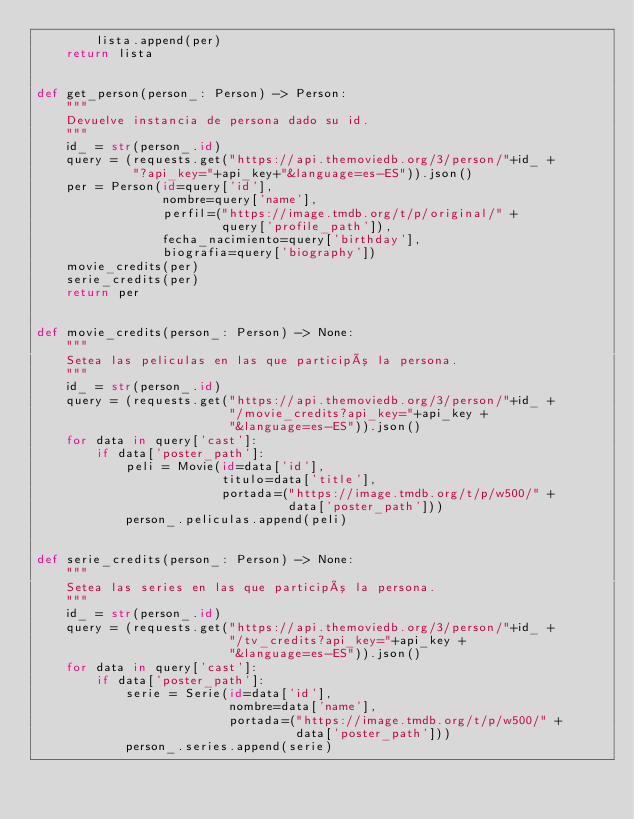Convert code to text. <code><loc_0><loc_0><loc_500><loc_500><_Python_>        lista.append(per)
    return lista


def get_person(person_: Person) -> Person:
    """
    Devuelve instancia de persona dado su id.
    """
    id_ = str(person_.id)
    query = (requests.get("https://api.themoviedb.org/3/person/"+id_ +
             "?api_key="+api_key+"&language=es-ES")).json()
    per = Person(id=query['id'],
                 nombre=query['name'],
                 perfil=("https://image.tmdb.org/t/p/original/" +
                         query['profile_path']),
                 fecha_nacimiento=query['birthday'],
                 biografia=query['biography'])
    movie_credits(per)
    serie_credits(per)
    return per


def movie_credits(person_: Person) -> None:
    """
    Setea las peliculas en las que participó la persona.
    """
    id_ = str(person_.id)
    query = (requests.get("https://api.themoviedb.org/3/person/"+id_ +
                          "/movie_credits?api_key="+api_key +
                          "&language=es-ES")).json()
    for data in query['cast']:
        if data['poster_path']:
            peli = Movie(id=data['id'],
                         titulo=data['title'],
                         portada=("https://image.tmdb.org/t/p/w500/" +
                                  data['poster_path']))
            person_.peliculas.append(peli)


def serie_credits(person_: Person) -> None:
    """
    Setea las series en las que participó la persona.
    """
    id_ = str(person_.id)
    query = (requests.get("https://api.themoviedb.org/3/person/"+id_ +
                          "/tv_credits?api_key="+api_key +
                          "&language=es-ES")).json()
    for data in query['cast']:
        if data['poster_path']:
            serie = Serie(id=data['id'],
                          nombre=data['name'],
                          portada=("https://image.tmdb.org/t/p/w500/" +
                                   data['poster_path']))
            person_.series.append(serie)
</code> 